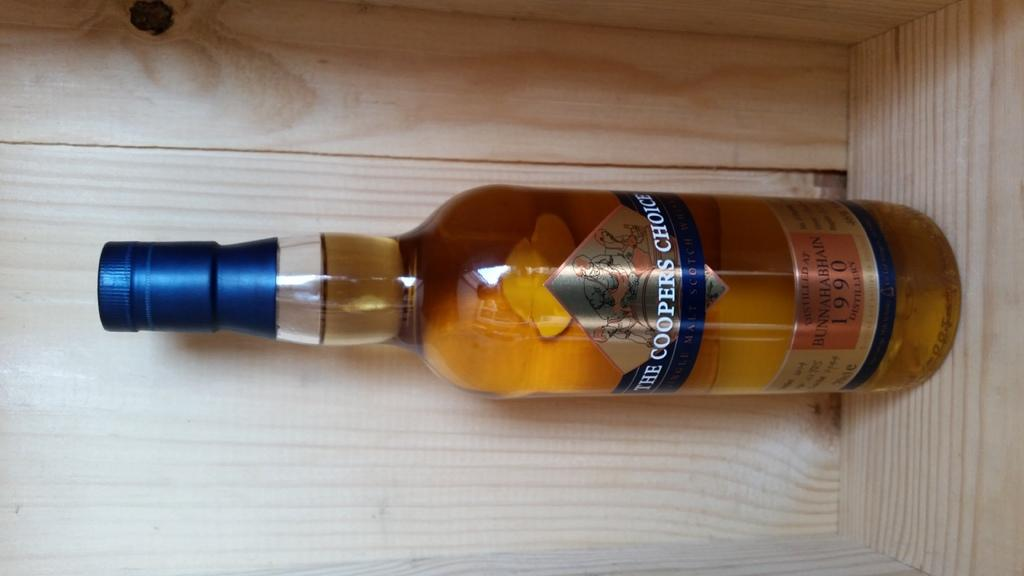<image>
Present a compact description of the photo's key features. A full bottle of The coopers choice whiskey 